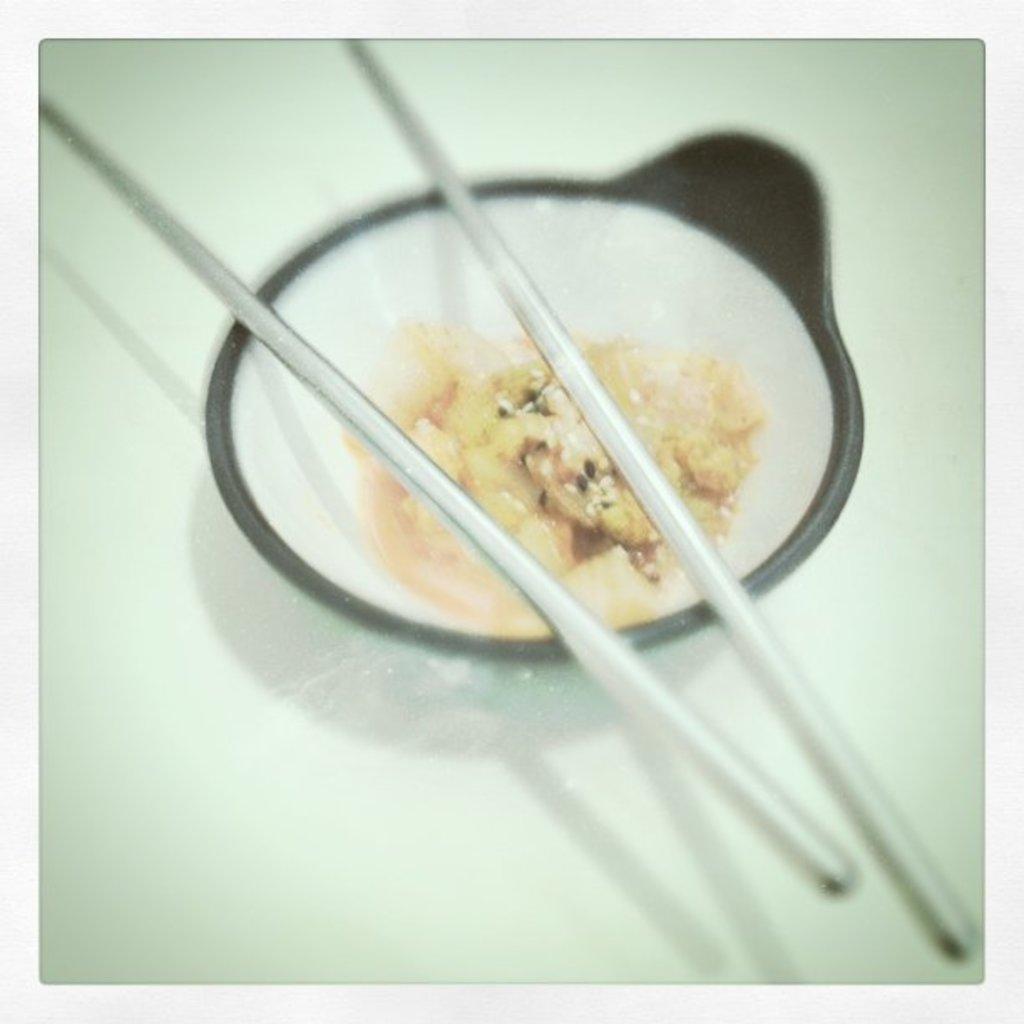Describe this image in one or two sentences. In this image there is a table and on top of that there is a bowl and food with chopsticks were present. 